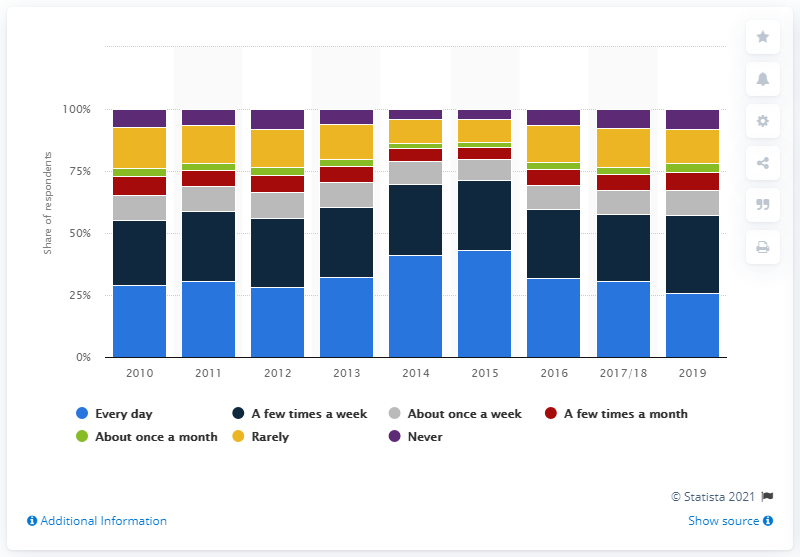Give some essential details in this illustration. In 2019, it was found that 25.8% of children were reading daily. 